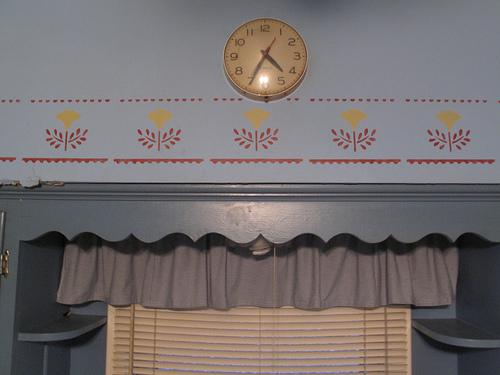Question: what is on the wall?
Choices:
A. Flowers.
B. Vines.
C. Drawings.
D. Dirt.
Answer with the letter. Answer: A Question: what color is the wall?
Choices:
A. Blue.
B. White.
C. Yellow.
D. Grey.
Answer with the letter. Answer: D Question: how many flowers?
Choices:
A. 7.
B. 5.
C. 8.
D. 9.
Answer with the letter. Answer: B Question: when was the picture taken?
Choices:
A. Dusk.
B. 4:35.
C. Morning.
D. Midnight.
Answer with the letter. Answer: B 